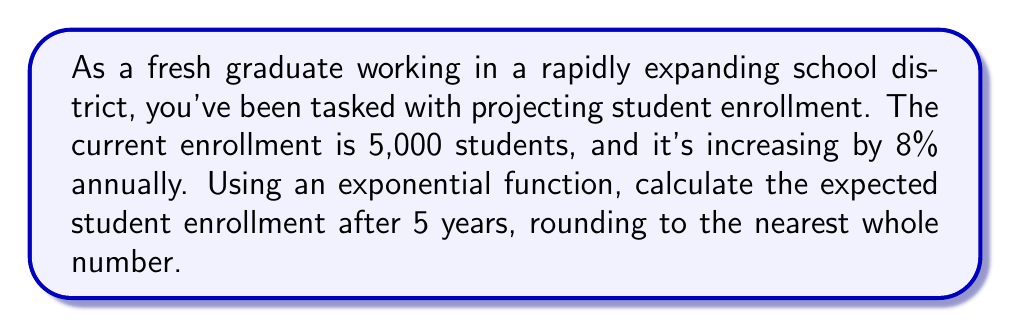What is the answer to this math problem? Let's approach this step-by-step:

1) The exponential growth function is given by:
   $$A = P(1 + r)^t$$
   Where:
   $A$ = Final amount
   $P$ = Initial principal balance
   $r$ = Growth rate (in decimal form)
   $t$ = Time period

2) We know:
   $P = 5,000$ (initial enrollment)
   $r = 8\% = 0.08$ (growth rate)
   $t = 5$ years

3) Let's substitute these values into our equation:
   $$A = 5000(1 + 0.08)^5$$

4) Simplify inside the parentheses:
   $$A = 5000(1.08)^5$$

5) Calculate the exponent:
   $$A = 5000 * 1.46933...$$

6) Multiply:
   $$A = 7346.65...$$

7) Rounding to the nearest whole number:
   $$A \approx 7,347 \text{ students}$$
Answer: 7,347 students 